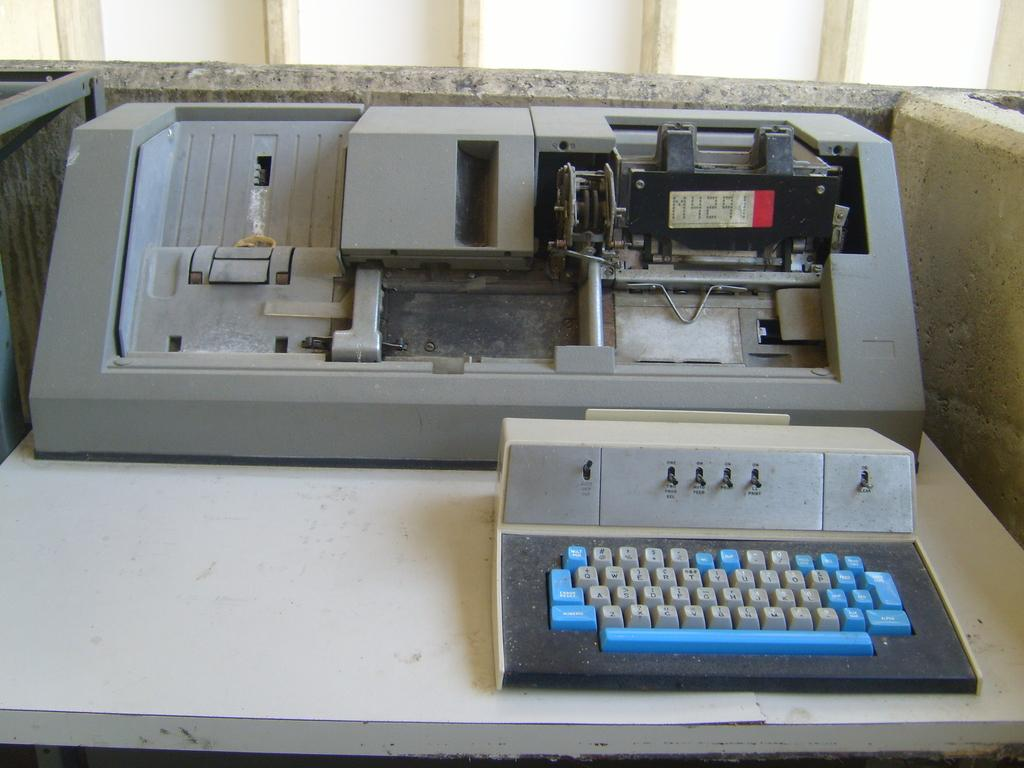<image>
Present a compact description of the photo's key features. A machine is marked as being a model M4291. 